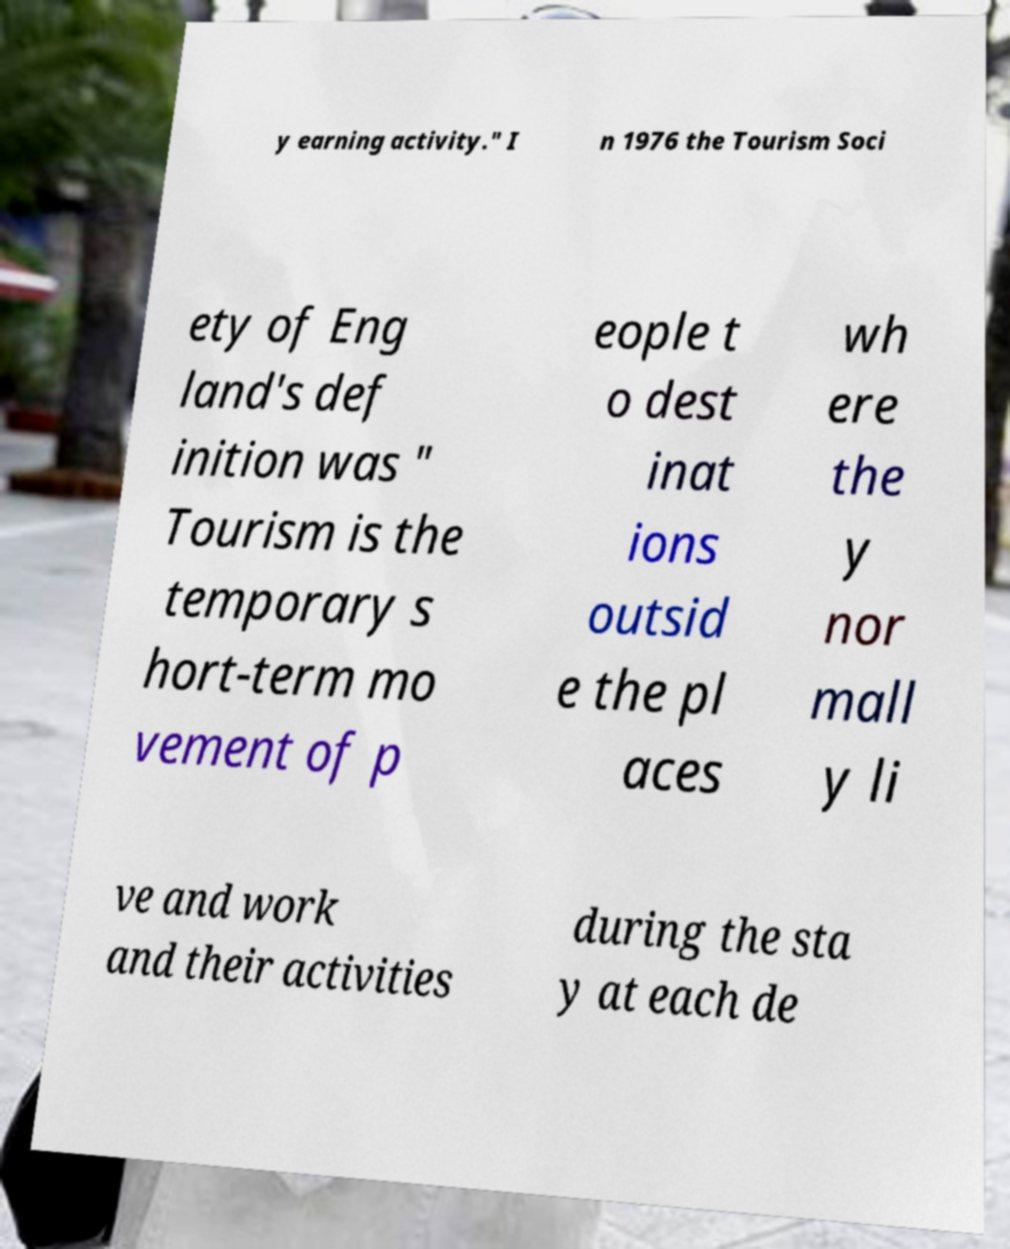Please read and relay the text visible in this image. What does it say? y earning activity." I n 1976 the Tourism Soci ety of Eng land's def inition was " Tourism is the temporary s hort-term mo vement of p eople t o dest inat ions outsid e the pl aces wh ere the y nor mall y li ve and work and their activities during the sta y at each de 